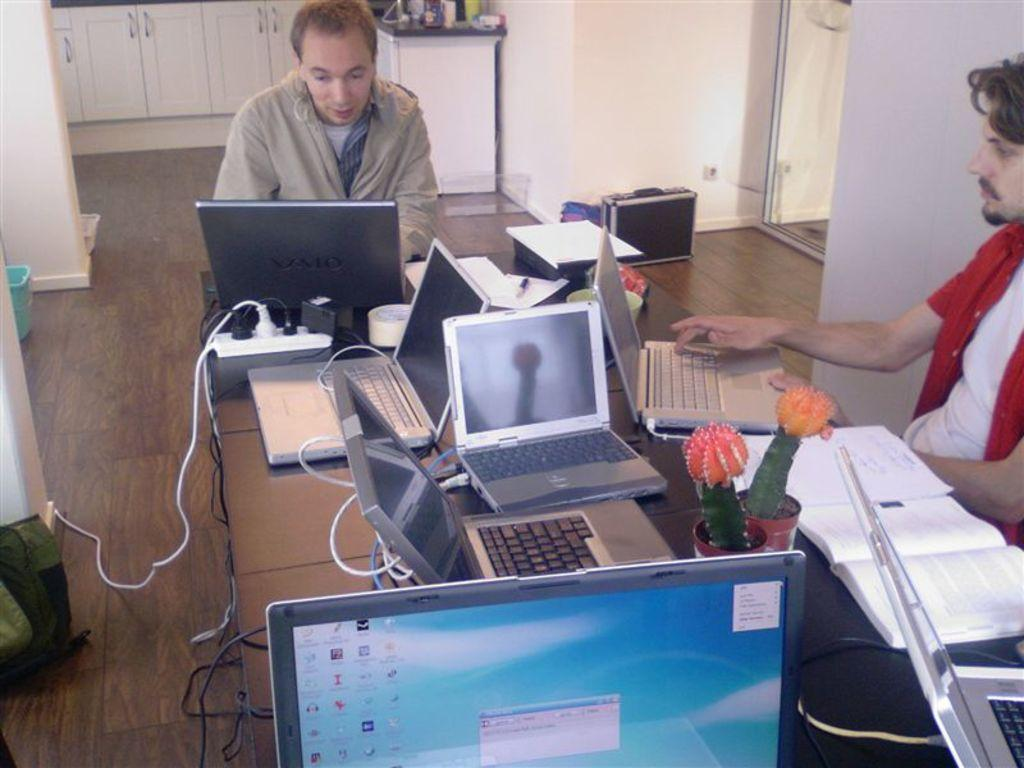<image>
Summarize the visual content of the image. a guy using a Vaio laptop working together with his coworker 